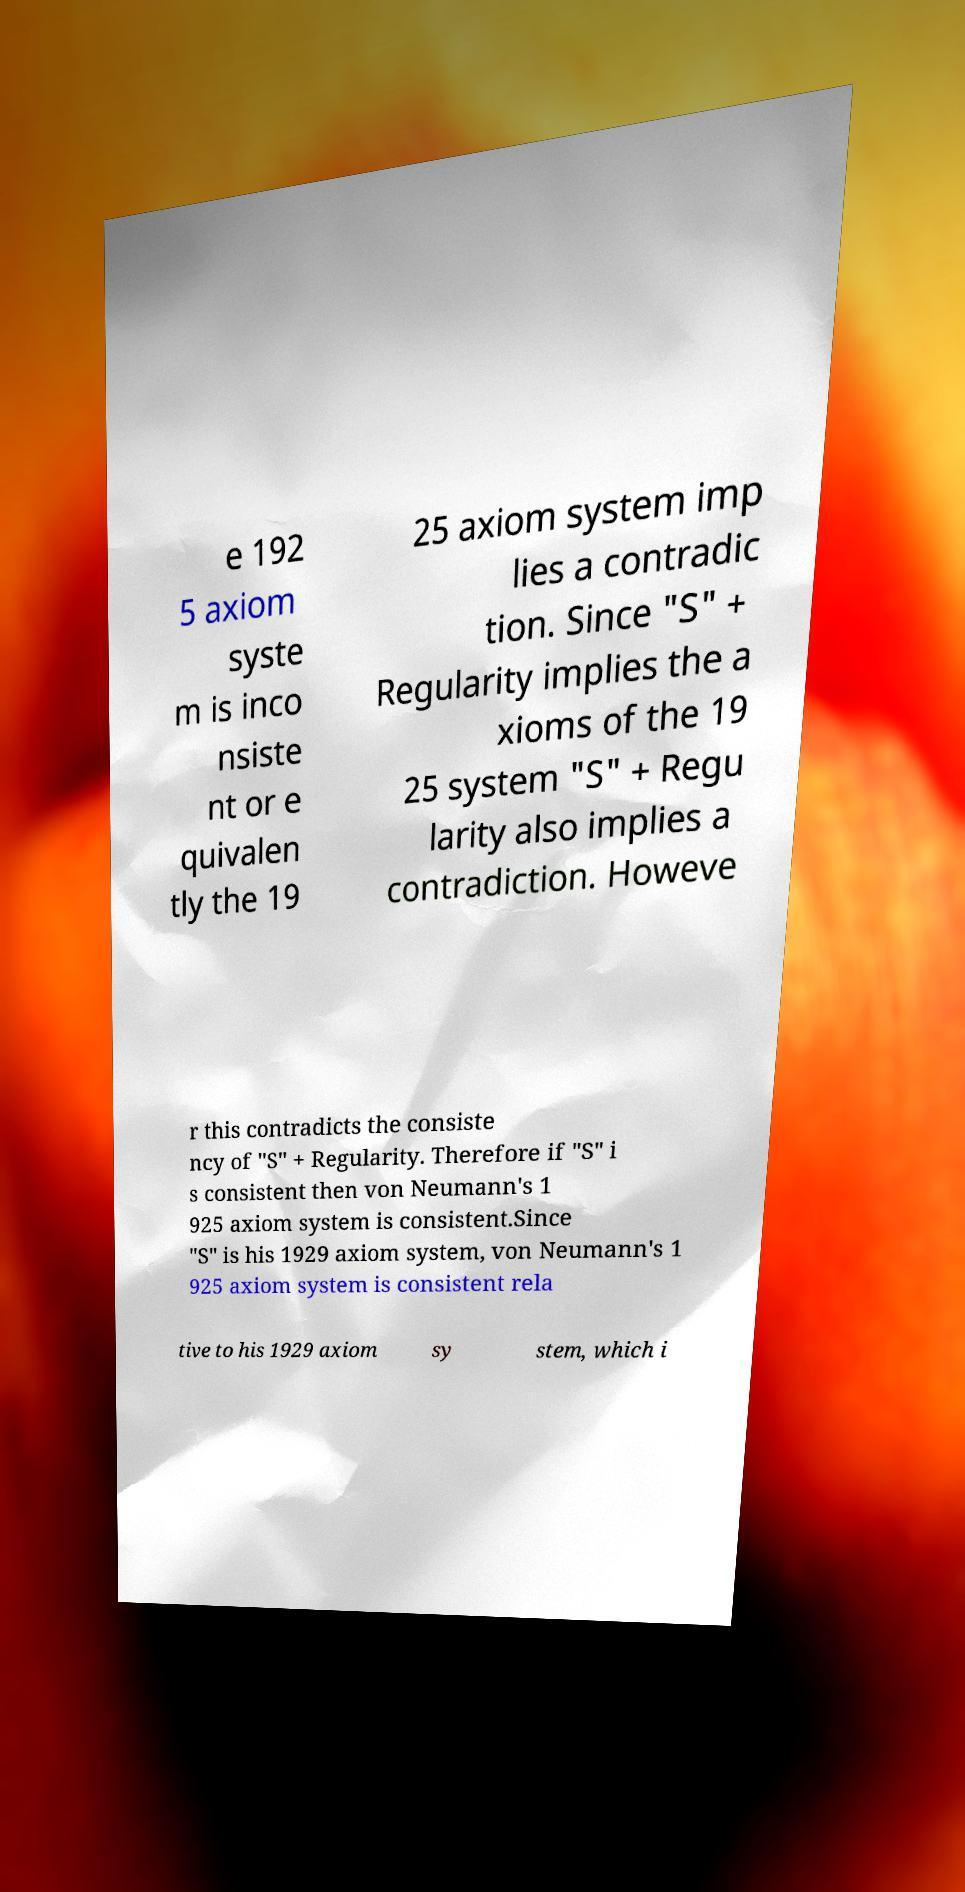Could you extract and type out the text from this image? e 192 5 axiom syste m is inco nsiste nt or e quivalen tly the 19 25 axiom system imp lies a contradic tion. Since "S" + Regularity implies the a xioms of the 19 25 system "S" + Regu larity also implies a contradiction. Howeve r this contradicts the consiste ncy of "S" + Regularity. Therefore if "S" i s consistent then von Neumann's 1 925 axiom system is consistent.Since "S" is his 1929 axiom system, von Neumann's 1 925 axiom system is consistent rela tive to his 1929 axiom sy stem, which i 